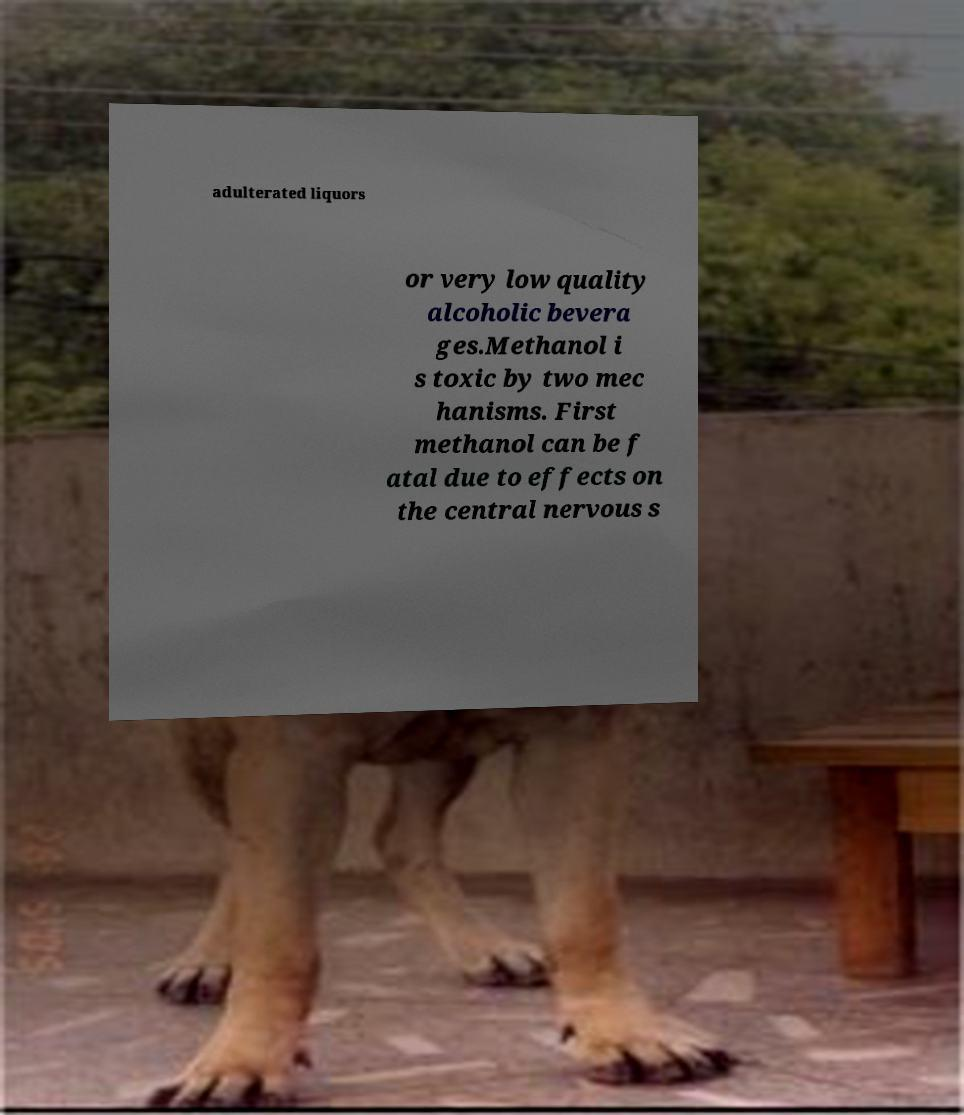Could you extract and type out the text from this image? adulterated liquors or very low quality alcoholic bevera ges.Methanol i s toxic by two mec hanisms. First methanol can be f atal due to effects on the central nervous s 